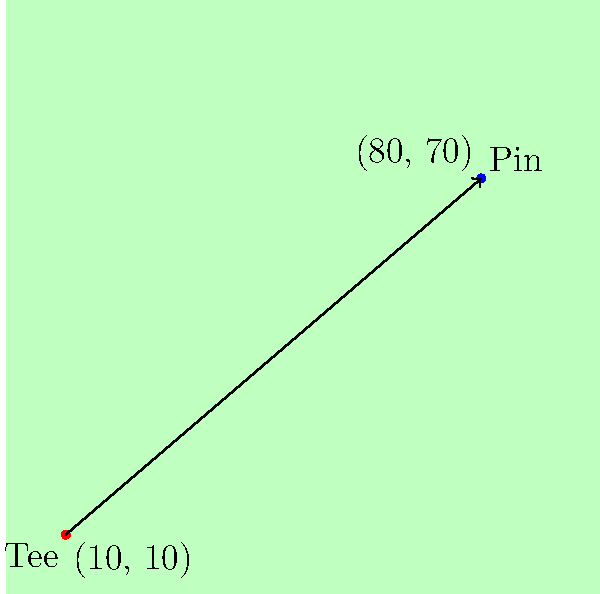As a golf pro exploring alternative training methods, you're working on improving your players' understanding of vector operations for course management. On a rectangular golf course map where each unit represents 1 yard, a golfer is at the tee position (10, 10) and needs to hit towards the pin at (80, 70). Calculate the distance to the pin and the angle (in degrees) between the shot vector and the positive x-axis. Let's approach this step-by-step using vector operations:

1. First, we need to find the vector from the tee to the pin:
   $\vec{v} = (80 - 10, 70 - 10) = (70, 60)$

2. To calculate the distance, we use the magnitude of this vector:
   $\text{Distance} = \|\vec{v}\| = \sqrt{70^2 + 60^2} = \sqrt{4900 + 3600} = \sqrt{8500} \approx 92.2$ yards

3. To find the angle, we can use the arctangent function:
   $\theta = \arctan(\frac{y}{x}) = \arctan(\frac{60}{70})$

4. However, we need to be careful with the arctangent function as it only gives values between $-\frac{\pi}{2}$ and $\frac{\pi}{2}$. In this case, both x and y are positive, so we're in the first quadrant and don't need to adjust.

5. Calculate the angle:
   $\theta = \arctan(\frac{60}{70}) \approx 0.7095$ radians

6. Convert to degrees:
   $\theta \approx 0.7095 \times \frac{180}{\pi} \approx 40.6$ degrees

Therefore, the distance to the pin is approximately 92.2 yards, and the angle between the shot vector and the positive x-axis is approximately 40.6 degrees.
Answer: Distance: 92.2 yards, Angle: 40.6 degrees 